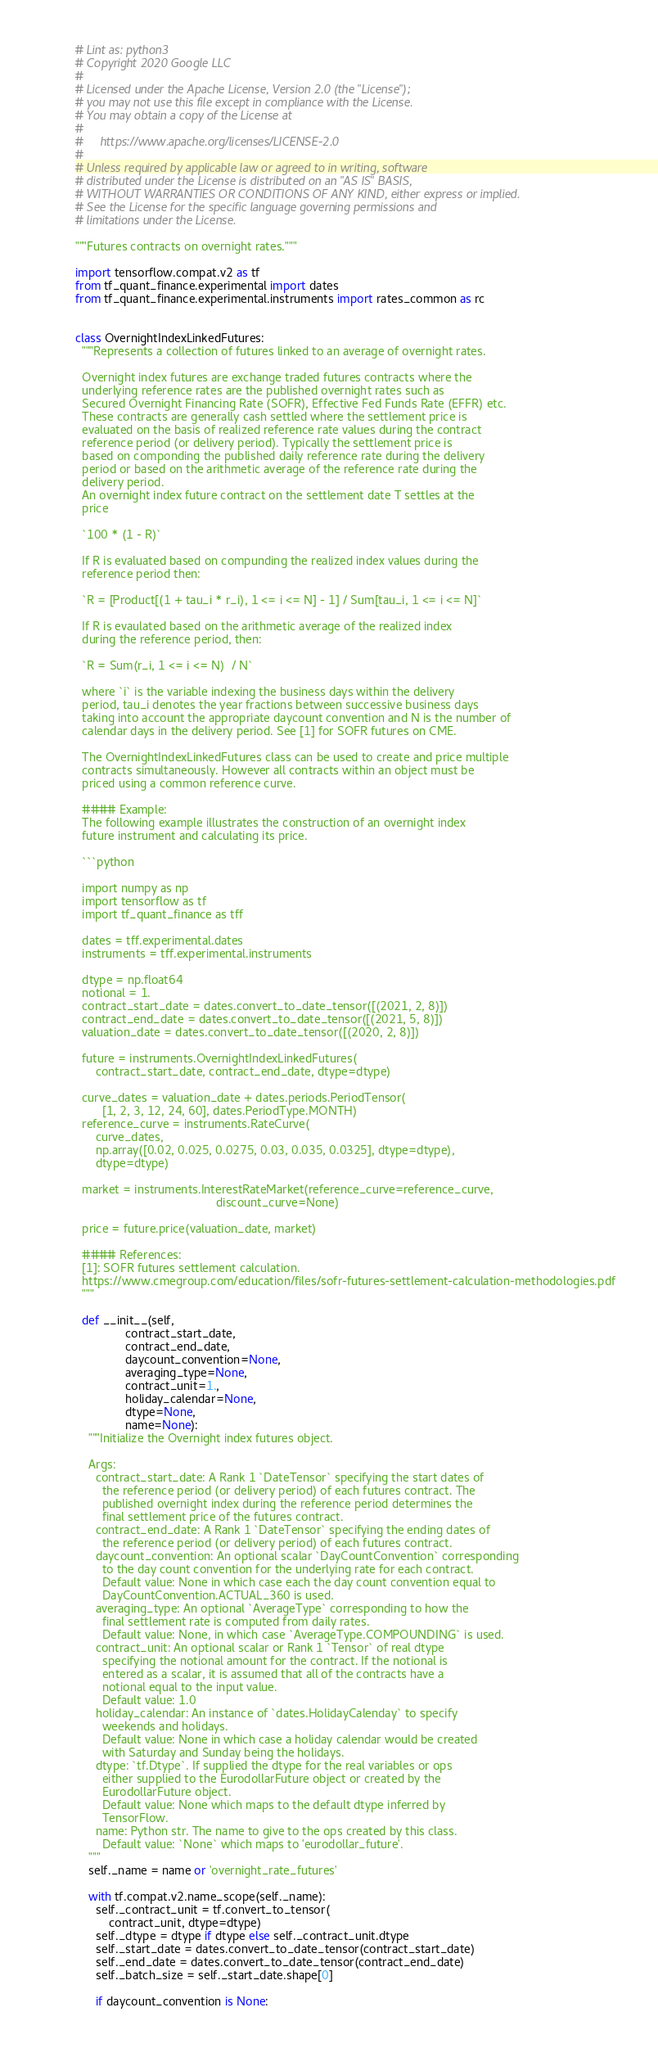Convert code to text. <code><loc_0><loc_0><loc_500><loc_500><_Python_># Lint as: python3
# Copyright 2020 Google LLC
#
# Licensed under the Apache License, Version 2.0 (the "License");
# you may not use this file except in compliance with the License.
# You may obtain a copy of the License at
#
#     https://www.apache.org/licenses/LICENSE-2.0
#
# Unless required by applicable law or agreed to in writing, software
# distributed under the License is distributed on an "AS IS" BASIS,
# WITHOUT WARRANTIES OR CONDITIONS OF ANY KIND, either express or implied.
# See the License for the specific language governing permissions and
# limitations under the License.

"""Futures contracts on overnight rates."""

import tensorflow.compat.v2 as tf
from tf_quant_finance.experimental import dates
from tf_quant_finance.experimental.instruments import rates_common as rc


class OvernightIndexLinkedFutures:
  """Represents a collection of futures linked to an average of overnight rates.

  Overnight index futures are exchange traded futures contracts where the
  underlying reference rates are the published overnight rates such as
  Secured Overnight Financing Rate (SOFR), Effective Fed Funds Rate (EFFR) etc.
  These contracts are generally cash settled where the settlement price is
  evaluated on the basis of realized reference rate values during the contract
  reference period (or delivery period). Typically the settlement price is
  based on componding the published daily reference rate during the delivery
  period or based on the arithmetic average of the reference rate during the
  delivery period.
  An overnight index future contract on the settlement date T settles at the
  price

  `100 * (1 - R)`

  If R is evaluated based on compunding the realized index values during the
  reference period then:

  `R = [Product[(1 + tau_i * r_i), 1 <= i <= N] - 1] / Sum[tau_i, 1 <= i <= N]`

  If R is evaulated based on the arithmetic average of the realized index
  during the reference period, then:

  `R = Sum(r_i, 1 <= i <= N)  / N`

  where `i` is the variable indexing the business days within the delivery
  period, tau_i denotes the year fractions between successive business days
  taking into account the appropriate daycount convention and N is the number of
  calendar days in the delivery period. See [1] for SOFR futures on CME.

  The OvernightIndexLinkedFutures class can be used to create and price multiple
  contracts simultaneously. However all contracts within an object must be
  priced using a common reference curve.

  #### Example:
  The following example illustrates the construction of an overnight index
  future instrument and calculating its price.

  ```python

  import numpy as np
  import tensorflow as tf
  import tf_quant_finance as tff

  dates = tff.experimental.dates
  instruments = tff.experimental.instruments

  dtype = np.float64
  notional = 1.
  contract_start_date = dates.convert_to_date_tensor([(2021, 2, 8)])
  contract_end_date = dates.convert_to_date_tensor([(2021, 5, 8)])
  valuation_date = dates.convert_to_date_tensor([(2020, 2, 8)])

  future = instruments.OvernightIndexLinkedFutures(
      contract_start_date, contract_end_date, dtype=dtype)

  curve_dates = valuation_date + dates.periods.PeriodTensor(
        [1, 2, 3, 12, 24, 60], dates.PeriodType.MONTH)
  reference_curve = instruments.RateCurve(
      curve_dates,
      np.array([0.02, 0.025, 0.0275, 0.03, 0.035, 0.0325], dtype=dtype),
      dtype=dtype)

  market = instruments.InterestRateMarket(reference_curve=reference_curve,
                                          discount_curve=None)

  price = future.price(valuation_date, market)

  #### References:
  [1]: SOFR futures settlement calculation.
  https://www.cmegroup.com/education/files/sofr-futures-settlement-calculation-methodologies.pdf
  """

  def __init__(self,
               contract_start_date,
               contract_end_date,
               daycount_convention=None,
               averaging_type=None,
               contract_unit=1.,
               holiday_calendar=None,
               dtype=None,
               name=None):
    """Initialize the Overnight index futures object.

    Args:
      contract_start_date: A Rank 1 `DateTensor` specifying the start dates of
        the reference period (or delivery period) of each futures contract. The
        published overnight index during the reference period determines the
        final settlement price of the futures contract.
      contract_end_date: A Rank 1 `DateTensor` specifying the ending dates of
        the reference period (or delivery period) of each futures contract.
      daycount_convention: An optional scalar `DayCountConvention` corresponding
        to the day count convention for the underlying rate for each contract.
        Default value: None in which case each the day count convention equal to
        DayCountConvention.ACTUAL_360 is used.
      averaging_type: An optional `AverageType` corresponding to how the
        final settlement rate is computed from daily rates.
        Default value: None, in which case `AverageType.COMPOUNDING` is used.
      contract_unit: An optional scalar or Rank 1 `Tensor` of real dtype
        specifying the notional amount for the contract. If the notional is
        entered as a scalar, it is assumed that all of the contracts have a
        notional equal to the input value.
        Default value: 1.0
      holiday_calendar: An instance of `dates.HolidayCalenday` to specify
        weekends and holidays.
        Default value: None in which case a holiday calendar would be created
        with Saturday and Sunday being the holidays.
      dtype: `tf.Dtype`. If supplied the dtype for the real variables or ops
        either supplied to the EurodollarFuture object or created by the
        EurodollarFuture object.
        Default value: None which maps to the default dtype inferred by
        TensorFlow.
      name: Python str. The name to give to the ops created by this class.
        Default value: `None` which maps to 'eurodollar_future'.
    """
    self._name = name or 'overnight_rate_futures'

    with tf.compat.v2.name_scope(self._name):
      self._contract_unit = tf.convert_to_tensor(
          contract_unit, dtype=dtype)
      self._dtype = dtype if dtype else self._contract_unit.dtype
      self._start_date = dates.convert_to_date_tensor(contract_start_date)
      self._end_date = dates.convert_to_date_tensor(contract_end_date)
      self._batch_size = self._start_date.shape[0]

      if daycount_convention is None:</code> 